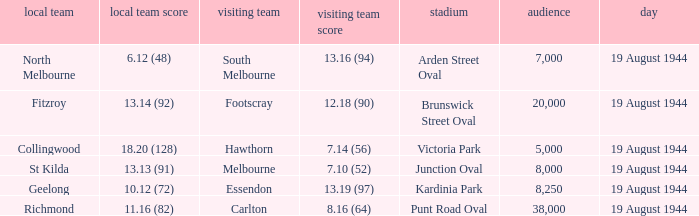What is Fitzroy's Home team score? 13.14 (92). 